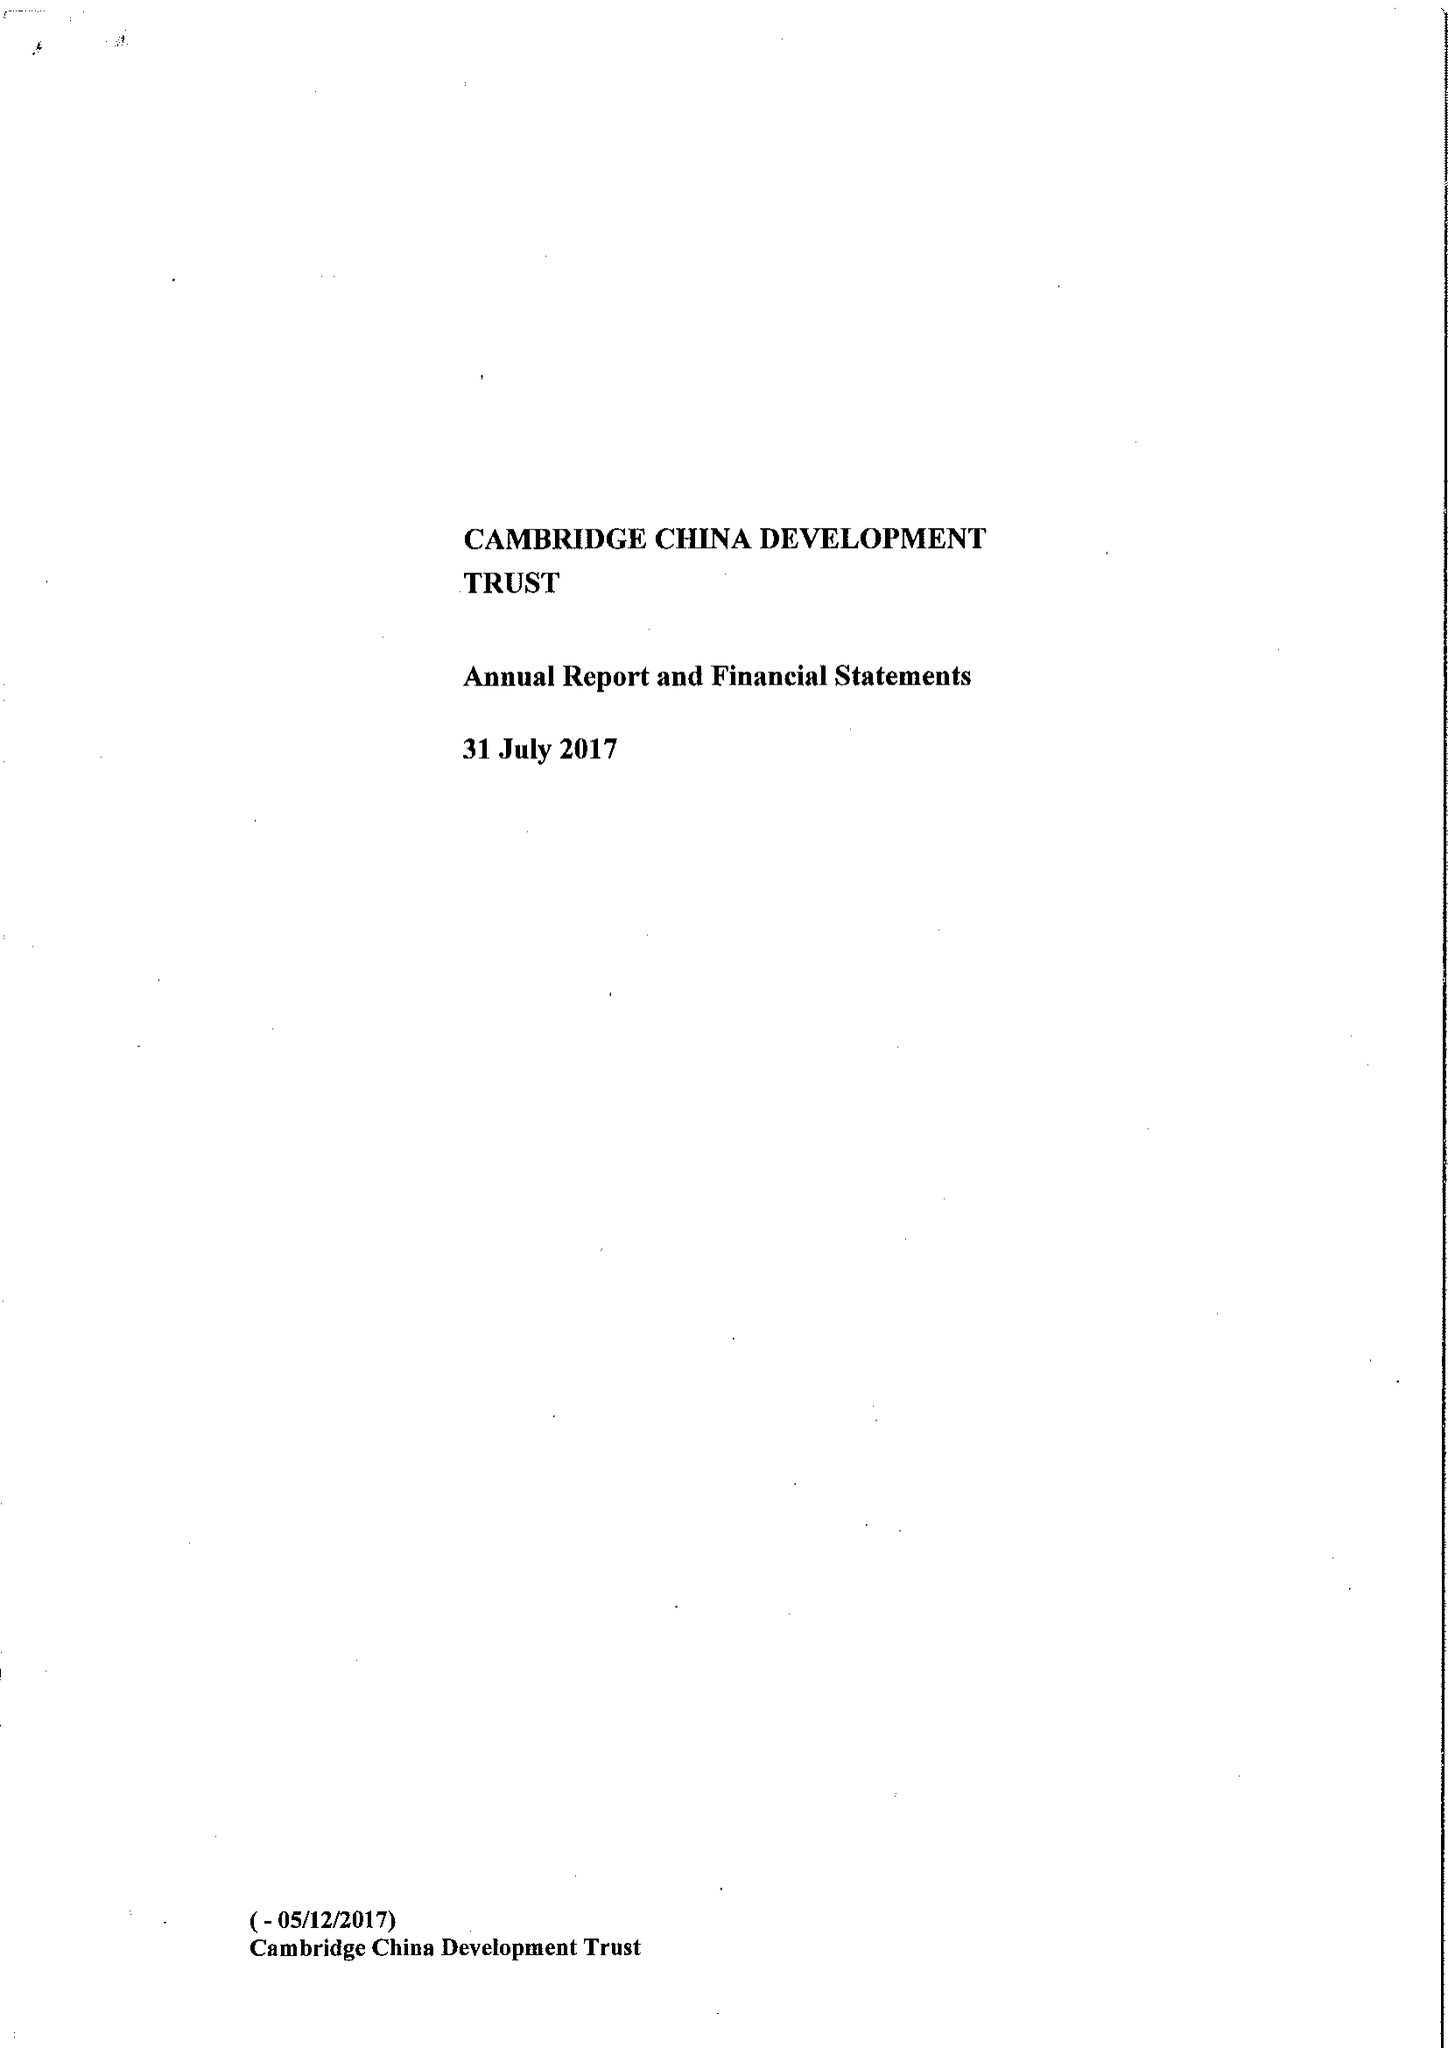What is the value for the report_date?
Answer the question using a single word or phrase. 2017-07-31 